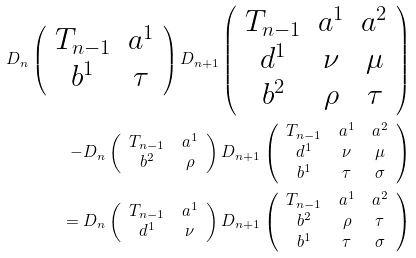Convert formula to latex. <formula><loc_0><loc_0><loc_500><loc_500>D _ { n } \left ( \begin{array} { c c } T _ { n - 1 } & a ^ { 1 } \\ b ^ { 1 } & \tau \end{array} \right ) D _ { n + 1 } \left ( \begin{array} { c c c } T _ { n - 1 } & a ^ { 1 } & a ^ { 2 } \\ d ^ { 1 } & \nu & \mu \\ b ^ { 2 } & \rho & \tau \end{array} \right ) \\ - D _ { n } \left ( \begin{array} { c c } T _ { n - 1 } & a ^ { 1 } \\ b ^ { 2 } & \rho \end{array} \right ) D _ { n + 1 } \left ( \begin{array} { c c c } T _ { n - 1 } & a ^ { 1 } & a ^ { 2 } \\ d ^ { 1 } & \nu & \mu \\ b ^ { 1 } & \tau & \sigma \end{array} \right ) \\ \quad = D _ { n } \left ( \begin{array} { c c } T _ { n - 1 } & a ^ { 1 } \\ d ^ { 1 } & \nu \end{array} \right ) D _ { n + 1 } \left ( \begin{array} { c c c } T _ { n - 1 } & a ^ { 1 } & a ^ { 2 } \\ b ^ { 2 } & \rho & \tau \\ b ^ { 1 } & \tau & \sigma \end{array} \right )</formula> 